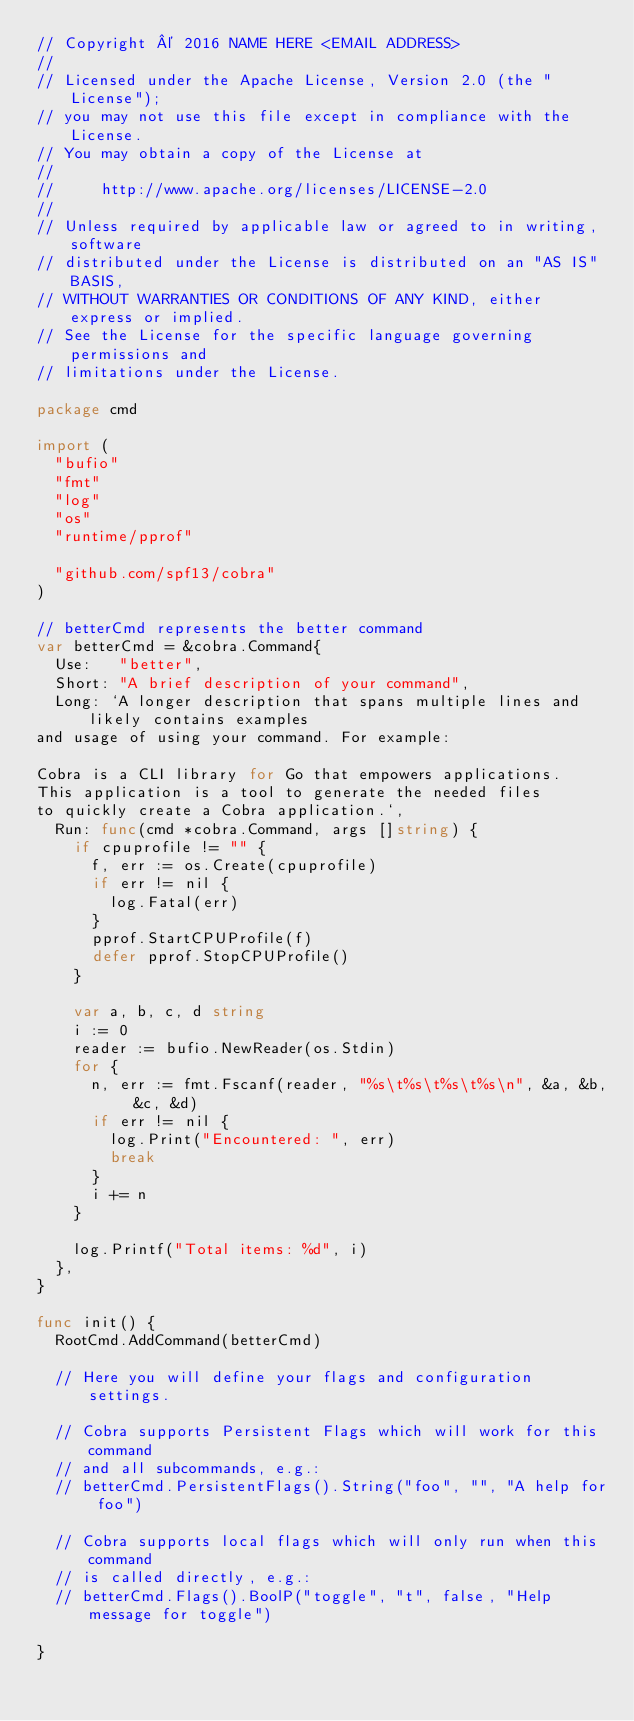Convert code to text. <code><loc_0><loc_0><loc_500><loc_500><_Go_>// Copyright © 2016 NAME HERE <EMAIL ADDRESS>
//
// Licensed under the Apache License, Version 2.0 (the "License");
// you may not use this file except in compliance with the License.
// You may obtain a copy of the License at
//
//     http://www.apache.org/licenses/LICENSE-2.0
//
// Unless required by applicable law or agreed to in writing, software
// distributed under the License is distributed on an "AS IS" BASIS,
// WITHOUT WARRANTIES OR CONDITIONS OF ANY KIND, either express or implied.
// See the License for the specific language governing permissions and
// limitations under the License.

package cmd

import (
	"bufio"
	"fmt"
	"log"
	"os"
	"runtime/pprof"

	"github.com/spf13/cobra"
)

// betterCmd represents the better command
var betterCmd = &cobra.Command{
	Use:   "better",
	Short: "A brief description of your command",
	Long: `A longer description that spans multiple lines and likely contains examples
and usage of using your command. For example:

Cobra is a CLI library for Go that empowers applications.
This application is a tool to generate the needed files
to quickly create a Cobra application.`,
	Run: func(cmd *cobra.Command, args []string) {
		if cpuprofile != "" {
			f, err := os.Create(cpuprofile)
			if err != nil {
				log.Fatal(err)
			}
			pprof.StartCPUProfile(f)
			defer pprof.StopCPUProfile()
		}

		var a, b, c, d string
		i := 0
		reader := bufio.NewReader(os.Stdin)
		for {
			n, err := fmt.Fscanf(reader, "%s\t%s\t%s\t%s\n", &a, &b, &c, &d)
			if err != nil {
				log.Print("Encountered: ", err)
				break
			}
			i += n
		}

		log.Printf("Total items: %d", i)
	},
}

func init() {
	RootCmd.AddCommand(betterCmd)

	// Here you will define your flags and configuration settings.

	// Cobra supports Persistent Flags which will work for this command
	// and all subcommands, e.g.:
	// betterCmd.PersistentFlags().String("foo", "", "A help for foo")

	// Cobra supports local flags which will only run when this command
	// is called directly, e.g.:
	// betterCmd.Flags().BoolP("toggle", "t", false, "Help message for toggle")

}
</code> 